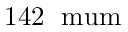<formula> <loc_0><loc_0><loc_500><loc_500>1 4 2 \, \ m u m</formula> 